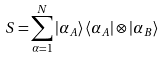Convert formula to latex. <formula><loc_0><loc_0><loc_500><loc_500>S = \overset { N } { \underset { \alpha = 1 } { \sum } } \left | \alpha _ { A } \right \rangle \left \langle \alpha _ { A } \right | \otimes \left | \alpha _ { B } \right \rangle</formula> 